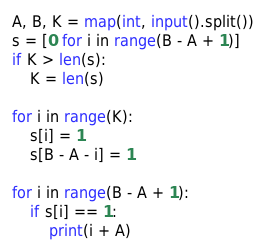Convert code to text. <code><loc_0><loc_0><loc_500><loc_500><_Python_>A, B, K = map(int, input().split())
s = [0 for i in range(B - A + 1)]
if K > len(s):
    K = len(s)
    
for i in range(K):
    s[i] = 1
    s[B - A - i] = 1

for i in range(B - A + 1):
    if s[i] == 1:
        print(i + A)
</code> 